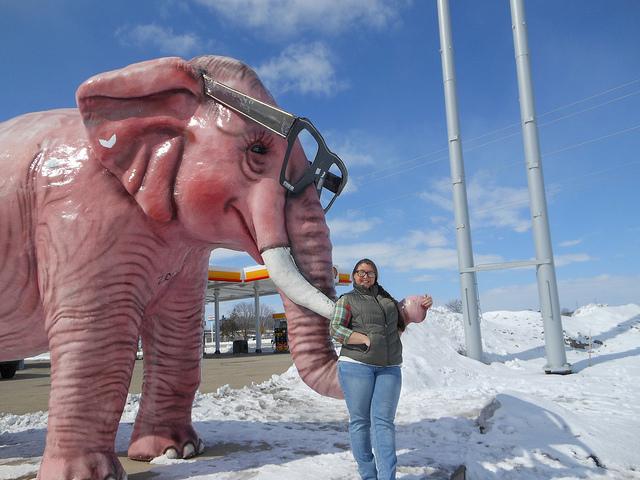Is this a toy elephant?
Answer briefly. Yes. Who is wearing glasses?
Keep it brief. Elephant. What is the woman standing by?
Write a very short answer. Elephant. 